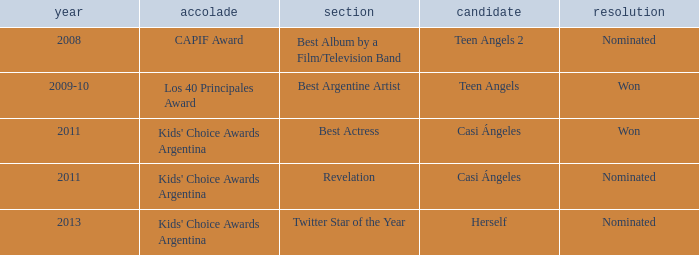What year was Teen Angels 2 nominated? 2008.0. 